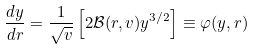Convert formula to latex. <formula><loc_0><loc_0><loc_500><loc_500>\frac { d y } { d r } = \frac { 1 } { \sqrt { v } } \left [ 2 { \mathcal { B } } ( r , v ) y ^ { 3 / 2 } \right ] \equiv \varphi ( y , r )</formula> 